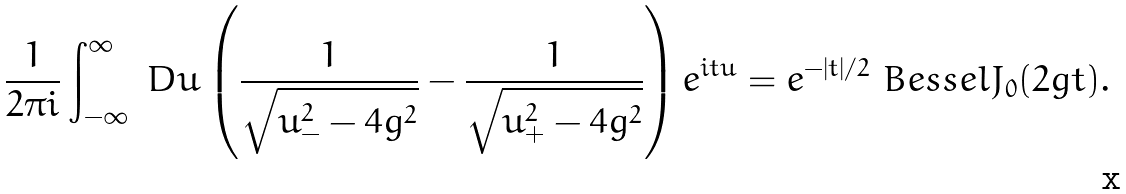Convert formula to latex. <formula><loc_0><loc_0><loc_500><loc_500>\frac { 1 } { 2 \pi i } \int _ { - \infty } ^ { \infty } \ D u \left ( \frac { 1 } { \sqrt { u ^ { 2 } _ { - } - 4 g ^ { 2 } } } - \frac { 1 } { \sqrt { u ^ { 2 } _ { + } - 4 g ^ { 2 } } } \right ) e ^ { i t u } = e ^ { - | t | / 2 } \ B e s s e l J _ { 0 } ( 2 g t ) .</formula> 